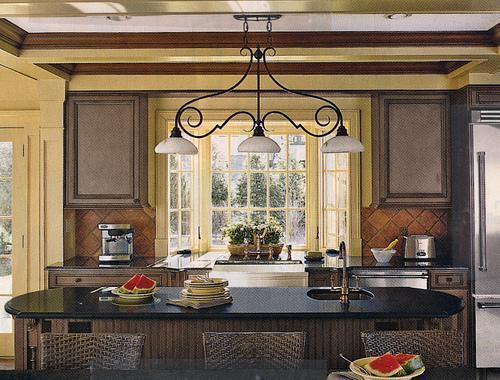How many faucets are there?
Give a very brief answer. 1. 